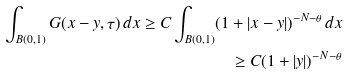<formula> <loc_0><loc_0><loc_500><loc_500>\int _ { B ( 0 , 1 ) } G ( x - y , \tau ) \, d x \geq C \int _ { B ( 0 , 1 ) } ( 1 + | x - y | ) ^ { - N - \theta } \, d x \\ \geq C ( 1 + | y | ) ^ { - N - \theta }</formula> 